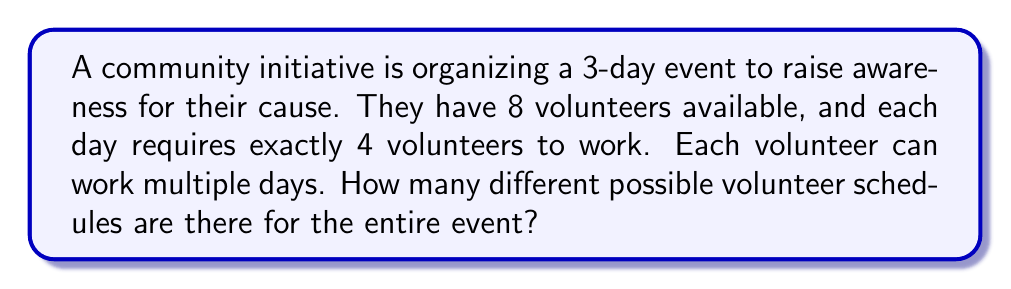Could you help me with this problem? Let's approach this step-by-step:

1) For each day, we need to select 4 volunteers out of 8. This is a combination problem.

2) The number of ways to select 4 volunteers out of 8 for a single day is:

   $$\binom{8}{4} = \frac{8!}{4!(8-4)!} = \frac{8!}{4!4!} = 70$$

3) This selection process is independent for each of the 3 days. Therefore, we can use the multiplication principle.

4) The total number of possible schedules is:

   $$70 \times 70 \times 70 = 70^3$$

5) Calculating this:

   $$70^3 = 343,000$$

Thus, there are 343,000 different possible volunteer schedules for the entire event.
Answer: 343,000 